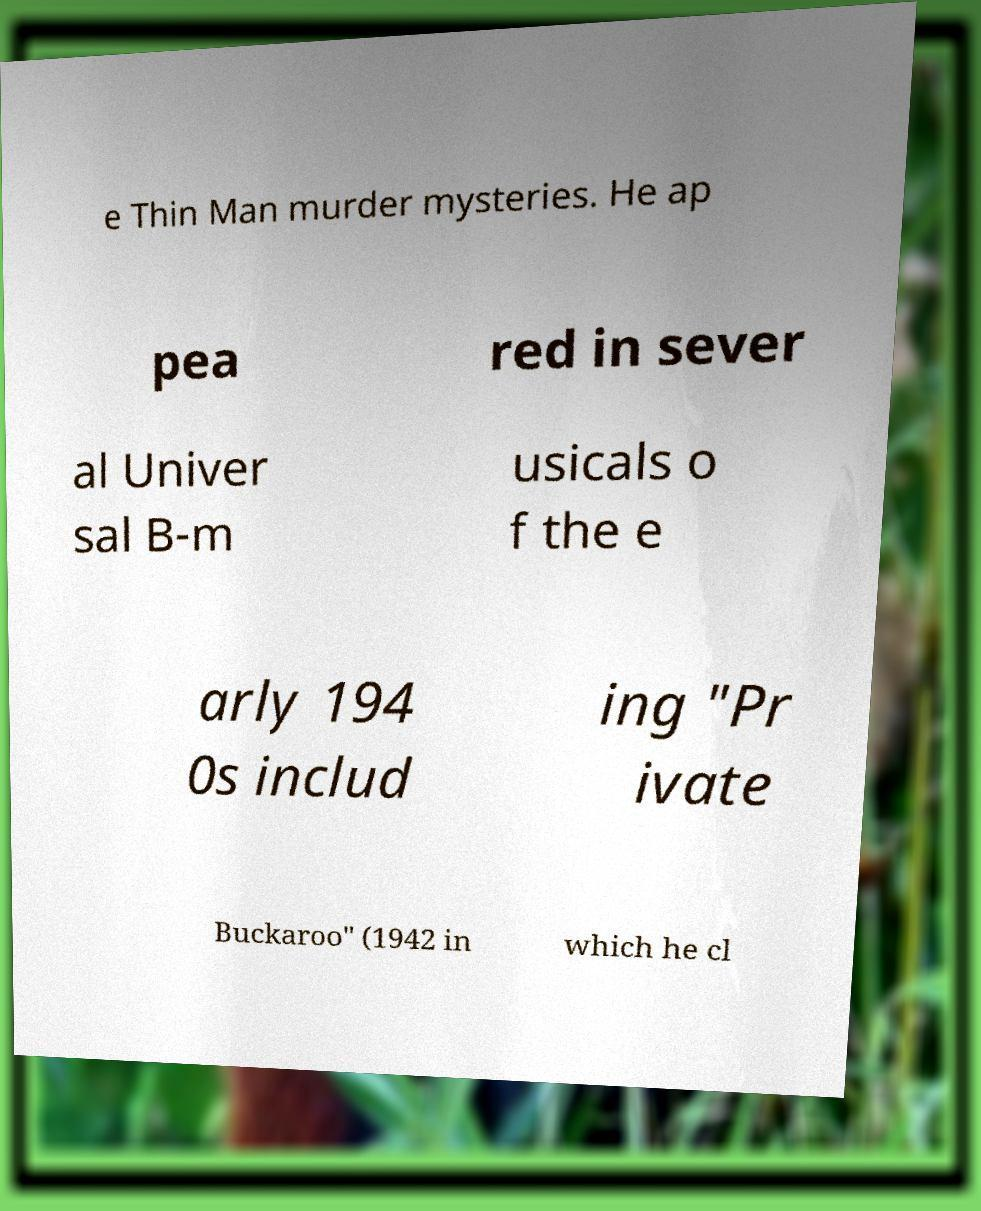There's text embedded in this image that I need extracted. Can you transcribe it verbatim? e Thin Man murder mysteries. He ap pea red in sever al Univer sal B-m usicals o f the e arly 194 0s includ ing "Pr ivate Buckaroo" (1942 in which he cl 